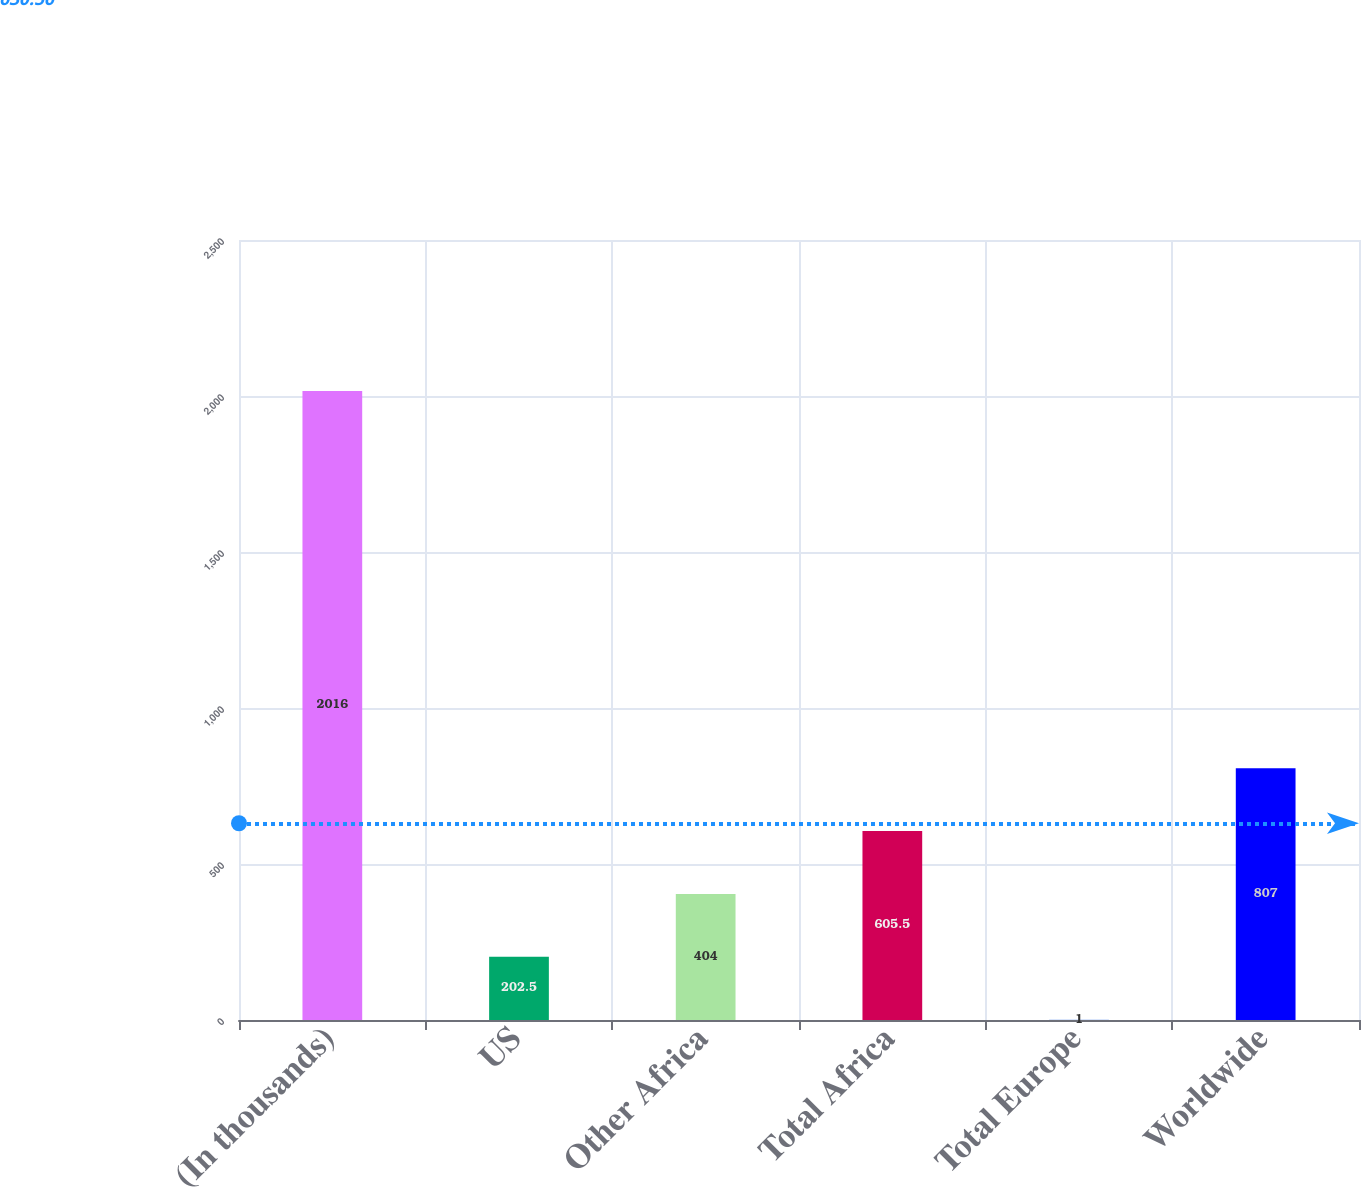Convert chart. <chart><loc_0><loc_0><loc_500><loc_500><bar_chart><fcel>(In thousands)<fcel>US<fcel>Other Africa<fcel>Total Africa<fcel>Total Europe<fcel>Worldwide<nl><fcel>2016<fcel>202.5<fcel>404<fcel>605.5<fcel>1<fcel>807<nl></chart> 